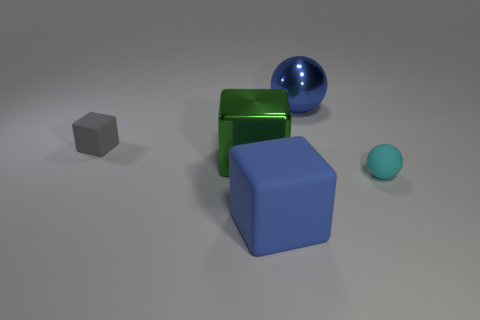Add 2 tiny rubber balls. How many objects exist? 7 Subtract all cubes. How many objects are left? 2 Add 3 large shiny spheres. How many large shiny spheres are left? 4 Add 3 big cyan cylinders. How many big cyan cylinders exist? 3 Subtract 0 yellow cylinders. How many objects are left? 5 Subtract all cyan balls. Subtract all small cyan objects. How many objects are left? 3 